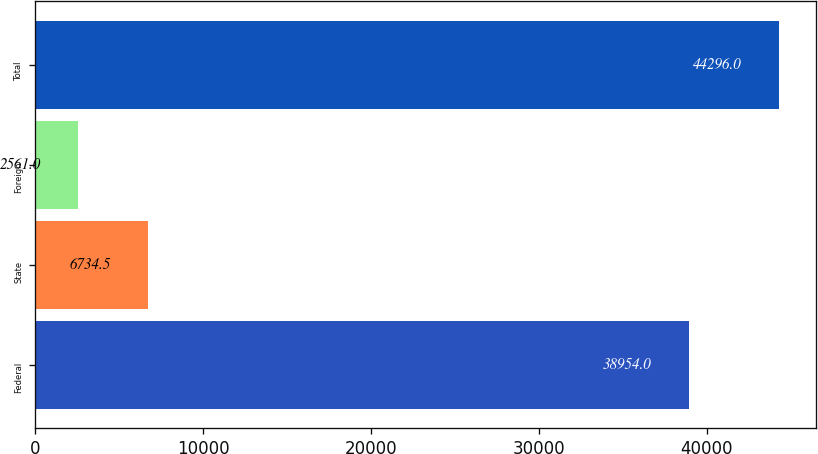<chart> <loc_0><loc_0><loc_500><loc_500><bar_chart><fcel>Federal<fcel>State<fcel>Foreign<fcel>Total<nl><fcel>38954<fcel>6734.5<fcel>2561<fcel>44296<nl></chart> 